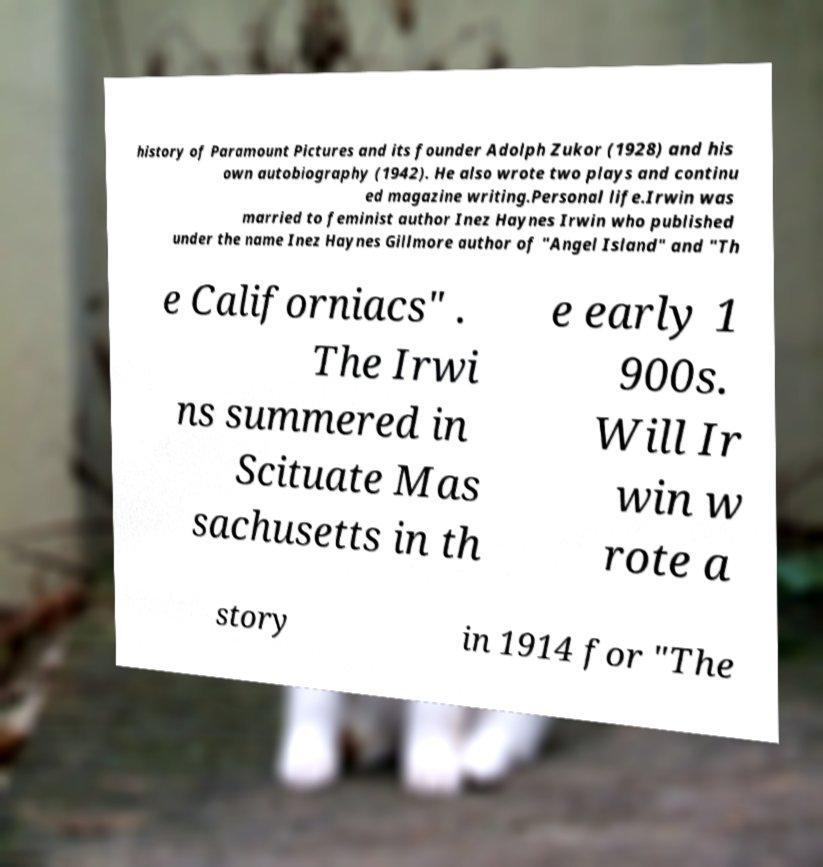Could you extract and type out the text from this image? history of Paramount Pictures and its founder Adolph Zukor (1928) and his own autobiography (1942). He also wrote two plays and continu ed magazine writing.Personal life.Irwin was married to feminist author Inez Haynes Irwin who published under the name Inez Haynes Gillmore author of "Angel Island" and "Th e Californiacs" . The Irwi ns summered in Scituate Mas sachusetts in th e early 1 900s. Will Ir win w rote a story in 1914 for "The 